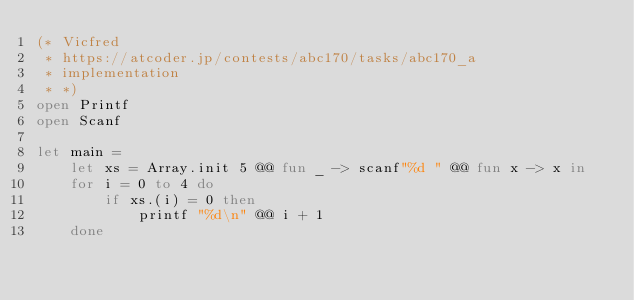Convert code to text. <code><loc_0><loc_0><loc_500><loc_500><_OCaml_>(* Vicfred
 * https://atcoder.jp/contests/abc170/tasks/abc170_a
 * implementation
 * *)
open Printf
open Scanf

let main =
    let xs = Array.init 5 @@ fun _ -> scanf"%d " @@ fun x -> x in
    for i = 0 to 4 do
        if xs.(i) = 0 then
            printf "%d\n" @@ i + 1
    done

</code> 